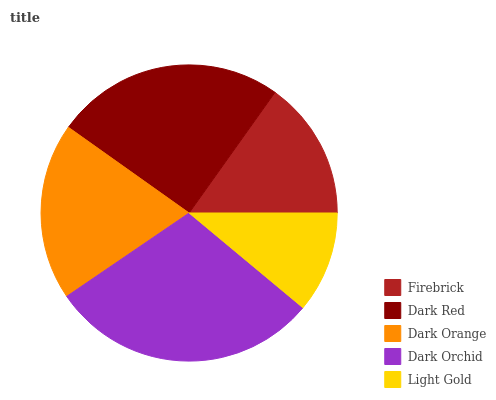Is Light Gold the minimum?
Answer yes or no. Yes. Is Dark Orchid the maximum?
Answer yes or no. Yes. Is Dark Red the minimum?
Answer yes or no. No. Is Dark Red the maximum?
Answer yes or no. No. Is Dark Red greater than Firebrick?
Answer yes or no. Yes. Is Firebrick less than Dark Red?
Answer yes or no. Yes. Is Firebrick greater than Dark Red?
Answer yes or no. No. Is Dark Red less than Firebrick?
Answer yes or no. No. Is Dark Orange the high median?
Answer yes or no. Yes. Is Dark Orange the low median?
Answer yes or no. Yes. Is Dark Orchid the high median?
Answer yes or no. No. Is Dark Red the low median?
Answer yes or no. No. 